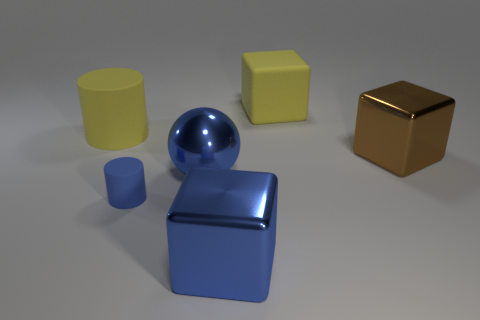Is the sphere the same color as the small cylinder?
Your answer should be compact. Yes. The metallic cube that is the same color as the small cylinder is what size?
Make the answer very short. Large. What is the material of the big blue ball?
Ensure brevity in your answer.  Metal. There is a metallic block to the right of the large blue shiny cube to the right of the small cylinder to the left of the big blue metal sphere; what is its color?
Your answer should be very brief. Brown. What material is the blue object that is the same shape as the large brown shiny thing?
Provide a short and direct response. Metal. What number of yellow blocks are the same size as the blue sphere?
Provide a succinct answer. 1. How many big yellow matte blocks are there?
Give a very brief answer. 1. Are the yellow block and the large brown object behind the blue sphere made of the same material?
Ensure brevity in your answer.  No. What number of red things are big blocks or matte blocks?
Your answer should be very brief. 0. There is a blue thing that is the same material as the large yellow cylinder; what is its size?
Provide a succinct answer. Small. 